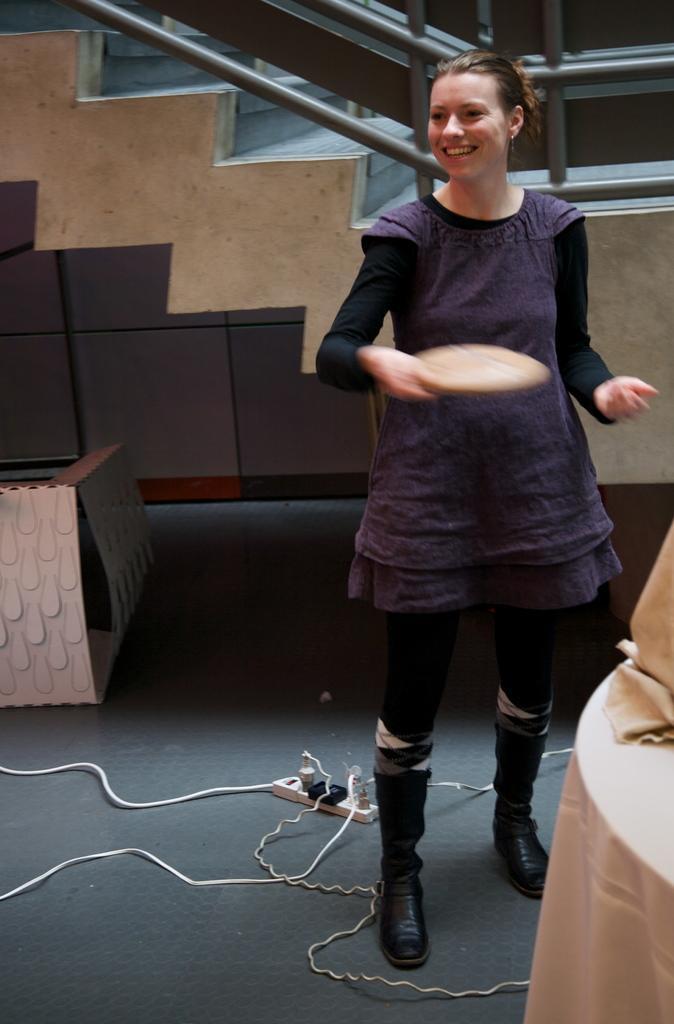Can you describe this image briefly? In this image in the center there is one woman who is standing and she is holding something, and on the right side there is a table. On the table there is some cloth and on the left side there is some object, at the bottom there is floor. On the floor there are some wires and in the background there is a staircase and a wall. 